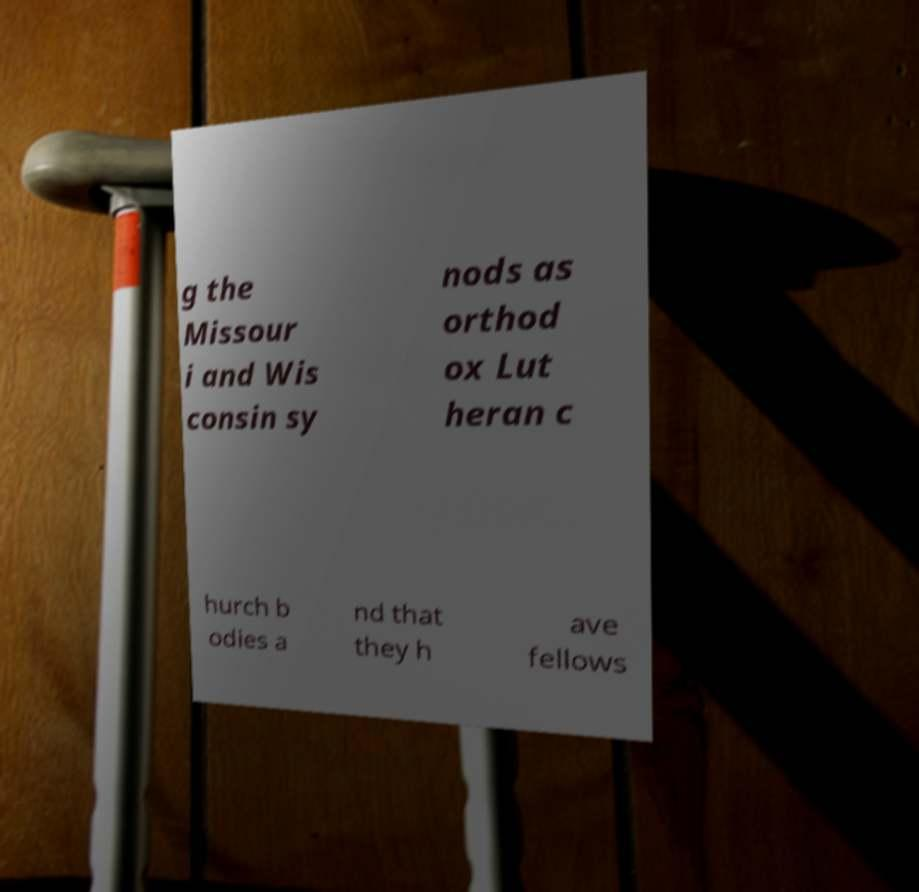Please identify and transcribe the text found in this image. g the Missour i and Wis consin sy nods as orthod ox Lut heran c hurch b odies a nd that they h ave fellows 